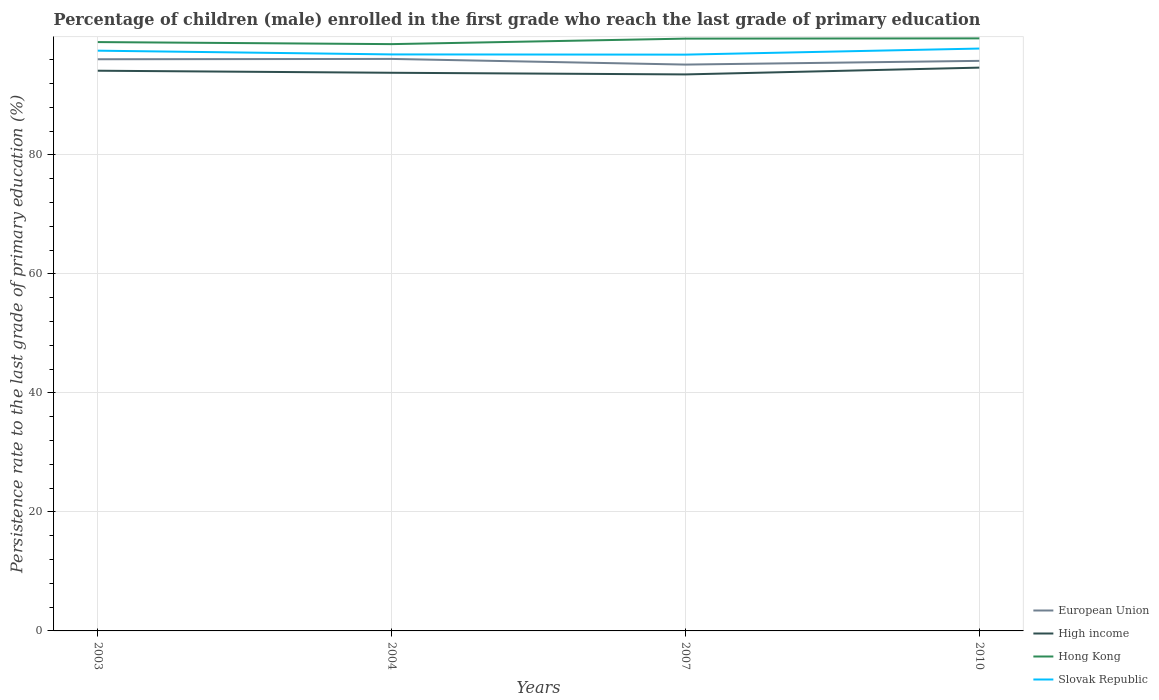Across all years, what is the maximum persistence rate of children in Hong Kong?
Your answer should be compact. 98.6. In which year was the persistence rate of children in Hong Kong maximum?
Make the answer very short. 2004. What is the total persistence rate of children in High income in the graph?
Offer a very short reply. 0.34. What is the difference between the highest and the second highest persistence rate of children in Hong Kong?
Provide a succinct answer. 0.97. What is the difference between the highest and the lowest persistence rate of children in Slovak Republic?
Keep it short and to the point. 2. How many years are there in the graph?
Your response must be concise. 4. Does the graph contain grids?
Give a very brief answer. Yes. How many legend labels are there?
Provide a short and direct response. 4. What is the title of the graph?
Keep it short and to the point. Percentage of children (male) enrolled in the first grade who reach the last grade of primary education. Does "Dominican Republic" appear as one of the legend labels in the graph?
Your answer should be compact. No. What is the label or title of the X-axis?
Offer a terse response. Years. What is the label or title of the Y-axis?
Keep it short and to the point. Persistence rate to the last grade of primary education (%). What is the Persistence rate to the last grade of primary education (%) of European Union in 2003?
Your answer should be compact. 96.06. What is the Persistence rate to the last grade of primary education (%) in High income in 2003?
Your answer should be very brief. 94.13. What is the Persistence rate to the last grade of primary education (%) in Hong Kong in 2003?
Give a very brief answer. 98.94. What is the Persistence rate to the last grade of primary education (%) of Slovak Republic in 2003?
Your response must be concise. 97.5. What is the Persistence rate to the last grade of primary education (%) in European Union in 2004?
Your answer should be very brief. 96.11. What is the Persistence rate to the last grade of primary education (%) of High income in 2004?
Offer a very short reply. 93.79. What is the Persistence rate to the last grade of primary education (%) in Hong Kong in 2004?
Provide a short and direct response. 98.6. What is the Persistence rate to the last grade of primary education (%) of Slovak Republic in 2004?
Offer a very short reply. 96.87. What is the Persistence rate to the last grade of primary education (%) in European Union in 2007?
Give a very brief answer. 95.16. What is the Persistence rate to the last grade of primary education (%) in High income in 2007?
Your answer should be very brief. 93.51. What is the Persistence rate to the last grade of primary education (%) in Hong Kong in 2007?
Your answer should be very brief. 99.52. What is the Persistence rate to the last grade of primary education (%) in Slovak Republic in 2007?
Keep it short and to the point. 96.83. What is the Persistence rate to the last grade of primary education (%) in European Union in 2010?
Ensure brevity in your answer.  95.79. What is the Persistence rate to the last grade of primary education (%) in High income in 2010?
Your response must be concise. 94.65. What is the Persistence rate to the last grade of primary education (%) of Hong Kong in 2010?
Ensure brevity in your answer.  99.56. What is the Persistence rate to the last grade of primary education (%) of Slovak Republic in 2010?
Your response must be concise. 97.85. Across all years, what is the maximum Persistence rate to the last grade of primary education (%) in European Union?
Provide a short and direct response. 96.11. Across all years, what is the maximum Persistence rate to the last grade of primary education (%) of High income?
Offer a very short reply. 94.65. Across all years, what is the maximum Persistence rate to the last grade of primary education (%) of Hong Kong?
Your response must be concise. 99.56. Across all years, what is the maximum Persistence rate to the last grade of primary education (%) in Slovak Republic?
Make the answer very short. 97.85. Across all years, what is the minimum Persistence rate to the last grade of primary education (%) in European Union?
Keep it short and to the point. 95.16. Across all years, what is the minimum Persistence rate to the last grade of primary education (%) of High income?
Offer a terse response. 93.51. Across all years, what is the minimum Persistence rate to the last grade of primary education (%) of Hong Kong?
Keep it short and to the point. 98.6. Across all years, what is the minimum Persistence rate to the last grade of primary education (%) in Slovak Republic?
Your response must be concise. 96.83. What is the total Persistence rate to the last grade of primary education (%) of European Union in the graph?
Offer a very short reply. 383.12. What is the total Persistence rate to the last grade of primary education (%) in High income in the graph?
Make the answer very short. 376.07. What is the total Persistence rate to the last grade of primary education (%) of Hong Kong in the graph?
Make the answer very short. 396.63. What is the total Persistence rate to the last grade of primary education (%) in Slovak Republic in the graph?
Make the answer very short. 389.05. What is the difference between the Persistence rate to the last grade of primary education (%) of European Union in 2003 and that in 2004?
Offer a very short reply. -0.06. What is the difference between the Persistence rate to the last grade of primary education (%) of High income in 2003 and that in 2004?
Your response must be concise. 0.34. What is the difference between the Persistence rate to the last grade of primary education (%) of Hong Kong in 2003 and that in 2004?
Keep it short and to the point. 0.34. What is the difference between the Persistence rate to the last grade of primary education (%) in Slovak Republic in 2003 and that in 2004?
Make the answer very short. 0.63. What is the difference between the Persistence rate to the last grade of primary education (%) of European Union in 2003 and that in 2007?
Give a very brief answer. 0.89. What is the difference between the Persistence rate to the last grade of primary education (%) in High income in 2003 and that in 2007?
Your answer should be compact. 0.62. What is the difference between the Persistence rate to the last grade of primary education (%) of Hong Kong in 2003 and that in 2007?
Your answer should be very brief. -0.58. What is the difference between the Persistence rate to the last grade of primary education (%) in Slovak Republic in 2003 and that in 2007?
Provide a succinct answer. 0.66. What is the difference between the Persistence rate to the last grade of primary education (%) of European Union in 2003 and that in 2010?
Offer a terse response. 0.27. What is the difference between the Persistence rate to the last grade of primary education (%) in High income in 2003 and that in 2010?
Your response must be concise. -0.52. What is the difference between the Persistence rate to the last grade of primary education (%) of Hong Kong in 2003 and that in 2010?
Provide a short and direct response. -0.62. What is the difference between the Persistence rate to the last grade of primary education (%) of Slovak Republic in 2003 and that in 2010?
Your response must be concise. -0.36. What is the difference between the Persistence rate to the last grade of primary education (%) of European Union in 2004 and that in 2007?
Make the answer very short. 0.95. What is the difference between the Persistence rate to the last grade of primary education (%) of High income in 2004 and that in 2007?
Provide a short and direct response. 0.28. What is the difference between the Persistence rate to the last grade of primary education (%) of Hong Kong in 2004 and that in 2007?
Offer a terse response. -0.92. What is the difference between the Persistence rate to the last grade of primary education (%) in Slovak Republic in 2004 and that in 2007?
Your answer should be compact. 0.04. What is the difference between the Persistence rate to the last grade of primary education (%) in European Union in 2004 and that in 2010?
Offer a very short reply. 0.32. What is the difference between the Persistence rate to the last grade of primary education (%) in High income in 2004 and that in 2010?
Offer a very short reply. -0.86. What is the difference between the Persistence rate to the last grade of primary education (%) in Hong Kong in 2004 and that in 2010?
Your answer should be compact. -0.97. What is the difference between the Persistence rate to the last grade of primary education (%) in Slovak Republic in 2004 and that in 2010?
Ensure brevity in your answer.  -0.98. What is the difference between the Persistence rate to the last grade of primary education (%) in European Union in 2007 and that in 2010?
Make the answer very short. -0.62. What is the difference between the Persistence rate to the last grade of primary education (%) of High income in 2007 and that in 2010?
Provide a succinct answer. -1.14. What is the difference between the Persistence rate to the last grade of primary education (%) in Hong Kong in 2007 and that in 2010?
Your answer should be very brief. -0.04. What is the difference between the Persistence rate to the last grade of primary education (%) in Slovak Republic in 2007 and that in 2010?
Offer a very short reply. -1.02. What is the difference between the Persistence rate to the last grade of primary education (%) in European Union in 2003 and the Persistence rate to the last grade of primary education (%) in High income in 2004?
Ensure brevity in your answer.  2.27. What is the difference between the Persistence rate to the last grade of primary education (%) of European Union in 2003 and the Persistence rate to the last grade of primary education (%) of Hong Kong in 2004?
Your response must be concise. -2.54. What is the difference between the Persistence rate to the last grade of primary education (%) of European Union in 2003 and the Persistence rate to the last grade of primary education (%) of Slovak Republic in 2004?
Your answer should be very brief. -0.81. What is the difference between the Persistence rate to the last grade of primary education (%) in High income in 2003 and the Persistence rate to the last grade of primary education (%) in Hong Kong in 2004?
Provide a succinct answer. -4.47. What is the difference between the Persistence rate to the last grade of primary education (%) in High income in 2003 and the Persistence rate to the last grade of primary education (%) in Slovak Republic in 2004?
Offer a very short reply. -2.74. What is the difference between the Persistence rate to the last grade of primary education (%) of Hong Kong in 2003 and the Persistence rate to the last grade of primary education (%) of Slovak Republic in 2004?
Provide a succinct answer. 2.07. What is the difference between the Persistence rate to the last grade of primary education (%) of European Union in 2003 and the Persistence rate to the last grade of primary education (%) of High income in 2007?
Your response must be concise. 2.55. What is the difference between the Persistence rate to the last grade of primary education (%) of European Union in 2003 and the Persistence rate to the last grade of primary education (%) of Hong Kong in 2007?
Offer a terse response. -3.47. What is the difference between the Persistence rate to the last grade of primary education (%) in European Union in 2003 and the Persistence rate to the last grade of primary education (%) in Slovak Republic in 2007?
Your answer should be compact. -0.78. What is the difference between the Persistence rate to the last grade of primary education (%) in High income in 2003 and the Persistence rate to the last grade of primary education (%) in Hong Kong in 2007?
Offer a terse response. -5.39. What is the difference between the Persistence rate to the last grade of primary education (%) of High income in 2003 and the Persistence rate to the last grade of primary education (%) of Slovak Republic in 2007?
Your answer should be very brief. -2.7. What is the difference between the Persistence rate to the last grade of primary education (%) in Hong Kong in 2003 and the Persistence rate to the last grade of primary education (%) in Slovak Republic in 2007?
Your answer should be compact. 2.11. What is the difference between the Persistence rate to the last grade of primary education (%) in European Union in 2003 and the Persistence rate to the last grade of primary education (%) in High income in 2010?
Your response must be concise. 1.41. What is the difference between the Persistence rate to the last grade of primary education (%) of European Union in 2003 and the Persistence rate to the last grade of primary education (%) of Hong Kong in 2010?
Offer a very short reply. -3.51. What is the difference between the Persistence rate to the last grade of primary education (%) of European Union in 2003 and the Persistence rate to the last grade of primary education (%) of Slovak Republic in 2010?
Provide a succinct answer. -1.8. What is the difference between the Persistence rate to the last grade of primary education (%) of High income in 2003 and the Persistence rate to the last grade of primary education (%) of Hong Kong in 2010?
Offer a very short reply. -5.43. What is the difference between the Persistence rate to the last grade of primary education (%) of High income in 2003 and the Persistence rate to the last grade of primary education (%) of Slovak Republic in 2010?
Provide a short and direct response. -3.72. What is the difference between the Persistence rate to the last grade of primary education (%) in Hong Kong in 2003 and the Persistence rate to the last grade of primary education (%) in Slovak Republic in 2010?
Give a very brief answer. 1.09. What is the difference between the Persistence rate to the last grade of primary education (%) in European Union in 2004 and the Persistence rate to the last grade of primary education (%) in High income in 2007?
Make the answer very short. 2.6. What is the difference between the Persistence rate to the last grade of primary education (%) of European Union in 2004 and the Persistence rate to the last grade of primary education (%) of Hong Kong in 2007?
Your answer should be very brief. -3.41. What is the difference between the Persistence rate to the last grade of primary education (%) of European Union in 2004 and the Persistence rate to the last grade of primary education (%) of Slovak Republic in 2007?
Your answer should be compact. -0.72. What is the difference between the Persistence rate to the last grade of primary education (%) in High income in 2004 and the Persistence rate to the last grade of primary education (%) in Hong Kong in 2007?
Offer a terse response. -5.74. What is the difference between the Persistence rate to the last grade of primary education (%) in High income in 2004 and the Persistence rate to the last grade of primary education (%) in Slovak Republic in 2007?
Provide a succinct answer. -3.05. What is the difference between the Persistence rate to the last grade of primary education (%) of Hong Kong in 2004 and the Persistence rate to the last grade of primary education (%) of Slovak Republic in 2007?
Give a very brief answer. 1.76. What is the difference between the Persistence rate to the last grade of primary education (%) in European Union in 2004 and the Persistence rate to the last grade of primary education (%) in High income in 2010?
Give a very brief answer. 1.46. What is the difference between the Persistence rate to the last grade of primary education (%) in European Union in 2004 and the Persistence rate to the last grade of primary education (%) in Hong Kong in 2010?
Your answer should be compact. -3.45. What is the difference between the Persistence rate to the last grade of primary education (%) in European Union in 2004 and the Persistence rate to the last grade of primary education (%) in Slovak Republic in 2010?
Your response must be concise. -1.74. What is the difference between the Persistence rate to the last grade of primary education (%) in High income in 2004 and the Persistence rate to the last grade of primary education (%) in Hong Kong in 2010?
Make the answer very short. -5.78. What is the difference between the Persistence rate to the last grade of primary education (%) in High income in 2004 and the Persistence rate to the last grade of primary education (%) in Slovak Republic in 2010?
Your response must be concise. -4.07. What is the difference between the Persistence rate to the last grade of primary education (%) of Hong Kong in 2004 and the Persistence rate to the last grade of primary education (%) of Slovak Republic in 2010?
Give a very brief answer. 0.74. What is the difference between the Persistence rate to the last grade of primary education (%) in European Union in 2007 and the Persistence rate to the last grade of primary education (%) in High income in 2010?
Ensure brevity in your answer.  0.51. What is the difference between the Persistence rate to the last grade of primary education (%) of European Union in 2007 and the Persistence rate to the last grade of primary education (%) of Hong Kong in 2010?
Offer a terse response. -4.4. What is the difference between the Persistence rate to the last grade of primary education (%) of European Union in 2007 and the Persistence rate to the last grade of primary education (%) of Slovak Republic in 2010?
Your response must be concise. -2.69. What is the difference between the Persistence rate to the last grade of primary education (%) in High income in 2007 and the Persistence rate to the last grade of primary education (%) in Hong Kong in 2010?
Ensure brevity in your answer.  -6.06. What is the difference between the Persistence rate to the last grade of primary education (%) of High income in 2007 and the Persistence rate to the last grade of primary education (%) of Slovak Republic in 2010?
Your answer should be very brief. -4.35. What is the difference between the Persistence rate to the last grade of primary education (%) in Hong Kong in 2007 and the Persistence rate to the last grade of primary education (%) in Slovak Republic in 2010?
Ensure brevity in your answer.  1.67. What is the average Persistence rate to the last grade of primary education (%) of European Union per year?
Your answer should be compact. 95.78. What is the average Persistence rate to the last grade of primary education (%) of High income per year?
Your response must be concise. 94.02. What is the average Persistence rate to the last grade of primary education (%) in Hong Kong per year?
Give a very brief answer. 99.16. What is the average Persistence rate to the last grade of primary education (%) in Slovak Republic per year?
Give a very brief answer. 97.26. In the year 2003, what is the difference between the Persistence rate to the last grade of primary education (%) of European Union and Persistence rate to the last grade of primary education (%) of High income?
Give a very brief answer. 1.93. In the year 2003, what is the difference between the Persistence rate to the last grade of primary education (%) in European Union and Persistence rate to the last grade of primary education (%) in Hong Kong?
Keep it short and to the point. -2.89. In the year 2003, what is the difference between the Persistence rate to the last grade of primary education (%) of European Union and Persistence rate to the last grade of primary education (%) of Slovak Republic?
Offer a very short reply. -1.44. In the year 2003, what is the difference between the Persistence rate to the last grade of primary education (%) in High income and Persistence rate to the last grade of primary education (%) in Hong Kong?
Your answer should be compact. -4.81. In the year 2003, what is the difference between the Persistence rate to the last grade of primary education (%) of High income and Persistence rate to the last grade of primary education (%) of Slovak Republic?
Your answer should be very brief. -3.37. In the year 2003, what is the difference between the Persistence rate to the last grade of primary education (%) in Hong Kong and Persistence rate to the last grade of primary education (%) in Slovak Republic?
Offer a terse response. 1.44. In the year 2004, what is the difference between the Persistence rate to the last grade of primary education (%) in European Union and Persistence rate to the last grade of primary education (%) in High income?
Provide a succinct answer. 2.33. In the year 2004, what is the difference between the Persistence rate to the last grade of primary education (%) of European Union and Persistence rate to the last grade of primary education (%) of Hong Kong?
Offer a very short reply. -2.49. In the year 2004, what is the difference between the Persistence rate to the last grade of primary education (%) of European Union and Persistence rate to the last grade of primary education (%) of Slovak Republic?
Provide a short and direct response. -0.76. In the year 2004, what is the difference between the Persistence rate to the last grade of primary education (%) of High income and Persistence rate to the last grade of primary education (%) of Hong Kong?
Provide a short and direct response. -4.81. In the year 2004, what is the difference between the Persistence rate to the last grade of primary education (%) in High income and Persistence rate to the last grade of primary education (%) in Slovak Republic?
Provide a short and direct response. -3.08. In the year 2004, what is the difference between the Persistence rate to the last grade of primary education (%) of Hong Kong and Persistence rate to the last grade of primary education (%) of Slovak Republic?
Offer a terse response. 1.73. In the year 2007, what is the difference between the Persistence rate to the last grade of primary education (%) of European Union and Persistence rate to the last grade of primary education (%) of High income?
Offer a terse response. 1.65. In the year 2007, what is the difference between the Persistence rate to the last grade of primary education (%) of European Union and Persistence rate to the last grade of primary education (%) of Hong Kong?
Give a very brief answer. -4.36. In the year 2007, what is the difference between the Persistence rate to the last grade of primary education (%) of European Union and Persistence rate to the last grade of primary education (%) of Slovak Republic?
Ensure brevity in your answer.  -1.67. In the year 2007, what is the difference between the Persistence rate to the last grade of primary education (%) in High income and Persistence rate to the last grade of primary education (%) in Hong Kong?
Give a very brief answer. -6.01. In the year 2007, what is the difference between the Persistence rate to the last grade of primary education (%) in High income and Persistence rate to the last grade of primary education (%) in Slovak Republic?
Your response must be concise. -3.33. In the year 2007, what is the difference between the Persistence rate to the last grade of primary education (%) of Hong Kong and Persistence rate to the last grade of primary education (%) of Slovak Republic?
Your response must be concise. 2.69. In the year 2010, what is the difference between the Persistence rate to the last grade of primary education (%) of European Union and Persistence rate to the last grade of primary education (%) of High income?
Offer a very short reply. 1.14. In the year 2010, what is the difference between the Persistence rate to the last grade of primary education (%) of European Union and Persistence rate to the last grade of primary education (%) of Hong Kong?
Provide a short and direct response. -3.78. In the year 2010, what is the difference between the Persistence rate to the last grade of primary education (%) of European Union and Persistence rate to the last grade of primary education (%) of Slovak Republic?
Give a very brief answer. -2.07. In the year 2010, what is the difference between the Persistence rate to the last grade of primary education (%) in High income and Persistence rate to the last grade of primary education (%) in Hong Kong?
Offer a very short reply. -4.91. In the year 2010, what is the difference between the Persistence rate to the last grade of primary education (%) in High income and Persistence rate to the last grade of primary education (%) in Slovak Republic?
Your answer should be very brief. -3.2. In the year 2010, what is the difference between the Persistence rate to the last grade of primary education (%) in Hong Kong and Persistence rate to the last grade of primary education (%) in Slovak Republic?
Make the answer very short. 1.71. What is the ratio of the Persistence rate to the last grade of primary education (%) in High income in 2003 to that in 2004?
Provide a short and direct response. 1. What is the ratio of the Persistence rate to the last grade of primary education (%) of Hong Kong in 2003 to that in 2004?
Keep it short and to the point. 1. What is the ratio of the Persistence rate to the last grade of primary education (%) of European Union in 2003 to that in 2007?
Your answer should be very brief. 1.01. What is the ratio of the Persistence rate to the last grade of primary education (%) in High income in 2003 to that in 2007?
Your response must be concise. 1.01. What is the ratio of the Persistence rate to the last grade of primary education (%) in Hong Kong in 2003 to that in 2007?
Give a very brief answer. 0.99. What is the ratio of the Persistence rate to the last grade of primary education (%) in Slovak Republic in 2003 to that in 2007?
Your answer should be very brief. 1.01. What is the ratio of the Persistence rate to the last grade of primary education (%) of European Union in 2003 to that in 2010?
Keep it short and to the point. 1. What is the ratio of the Persistence rate to the last grade of primary education (%) of Slovak Republic in 2003 to that in 2010?
Your response must be concise. 1. What is the ratio of the Persistence rate to the last grade of primary education (%) in High income in 2004 to that in 2007?
Offer a very short reply. 1. What is the ratio of the Persistence rate to the last grade of primary education (%) in Slovak Republic in 2004 to that in 2007?
Offer a very short reply. 1. What is the ratio of the Persistence rate to the last grade of primary education (%) of High income in 2004 to that in 2010?
Your answer should be compact. 0.99. What is the ratio of the Persistence rate to the last grade of primary education (%) of Hong Kong in 2004 to that in 2010?
Make the answer very short. 0.99. What is the ratio of the Persistence rate to the last grade of primary education (%) in European Union in 2007 to that in 2010?
Your response must be concise. 0.99. What is the ratio of the Persistence rate to the last grade of primary education (%) in High income in 2007 to that in 2010?
Your answer should be compact. 0.99. What is the difference between the highest and the second highest Persistence rate to the last grade of primary education (%) of European Union?
Give a very brief answer. 0.06. What is the difference between the highest and the second highest Persistence rate to the last grade of primary education (%) in High income?
Your answer should be compact. 0.52. What is the difference between the highest and the second highest Persistence rate to the last grade of primary education (%) of Hong Kong?
Your answer should be very brief. 0.04. What is the difference between the highest and the second highest Persistence rate to the last grade of primary education (%) in Slovak Republic?
Provide a short and direct response. 0.36. What is the difference between the highest and the lowest Persistence rate to the last grade of primary education (%) in European Union?
Provide a short and direct response. 0.95. What is the difference between the highest and the lowest Persistence rate to the last grade of primary education (%) of High income?
Give a very brief answer. 1.14. What is the difference between the highest and the lowest Persistence rate to the last grade of primary education (%) in Hong Kong?
Your response must be concise. 0.97. What is the difference between the highest and the lowest Persistence rate to the last grade of primary education (%) in Slovak Republic?
Your answer should be compact. 1.02. 